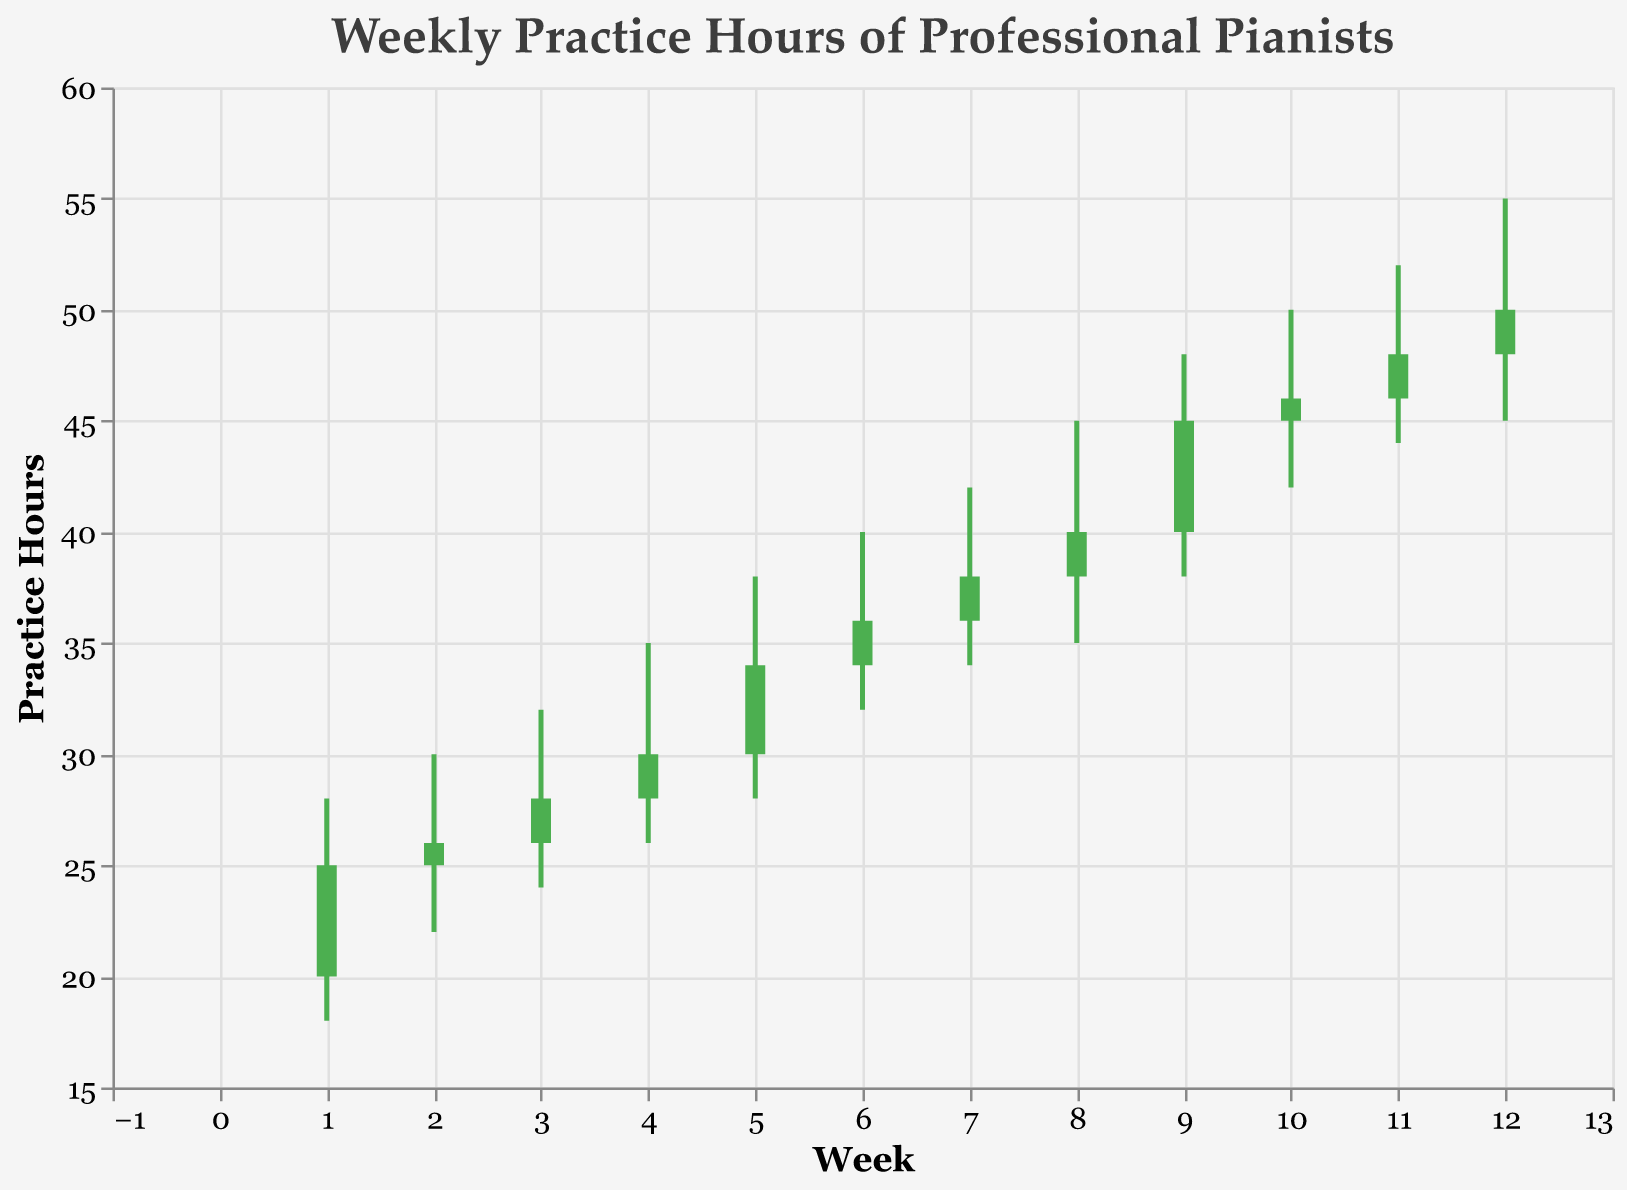What is the highest number of practice hours in a single week? The highest number of practice hours is represented by the highest point on the y-axis of the OHLC bars for each week. This occurs in Week 12, where the "High" value is 55.
Answer: 55 What is the trend of the closing practice hours over the weeks? To identify the trend, look at the "Close" values for each week and observe their progression. The "Close" values increase over time, indicating a rising trend.
Answer: Rising trend Which week shows the largest range between the highest and lowest practice hours? The range is calculated by subtracting the "Low" value from the "High" value for each week. Week 12 has the largest range (55 - 45 = 10).
Answer: Week 12 During which weeks did the practice hours remain the same or increase from open to close? This can be identified by examining the color of the OHLC bars. Green bars indicate that the "Close" value is higher than the "Open" value. Weeks 1, 2, 3, 4, 5, 6, 7, 8, 9, 10, 11, and 12 all show an increase or no change.
Answer: Weeks 1-12 How many weeks have a close value of 40 or higher? Look at the "Close" values and count how many weeks meet or exceed 40. Weeks 8, 9, 10, 11, and 12 all have close values 40 or higher.
Answer: 5 weeks What is the total range of practice hours from the lowest low to the highest high throughout the period? The total range is calculated by subtracting the lowest "Low" value from the highest "High" value across all weeks. The lowest "Low" is 18 in Week 1, and the highest "High" is 55 in Week 12. Therefore, the total range is 55 - 18 = 37 hours.
Answer: 37 hours In which week did the practice hours show the smallest difference between open and close? The smallest difference can be found by subtracting the "Open" value from the "Close" value for each week. Week 2 has the smallest difference (26 - 25 = 1).
Answer: Week 2 Which week has the highest increase in practice hours from open to close? To find this, calculate the difference between "Close" and "Open" for all weeks. Week 9 has the highest increase with (45 - 40 = 5).
Answer: Week 9 How does the practice hour trend in the first half of the period (Weeks 1-6) compare to the second half (Weeks 7-12)? Calculate the average "Close" values for the first half (Weeks 1-6) and the second half (Weeks 7-12). The first half average is (25+26+28+30+34+36)/6 = 29.83. The second half average is (38+40+45+46+48+50)/6 = 44.5. The second half shows a higher average close value, indicating more practice hours.
Answer: Second half has higher average 